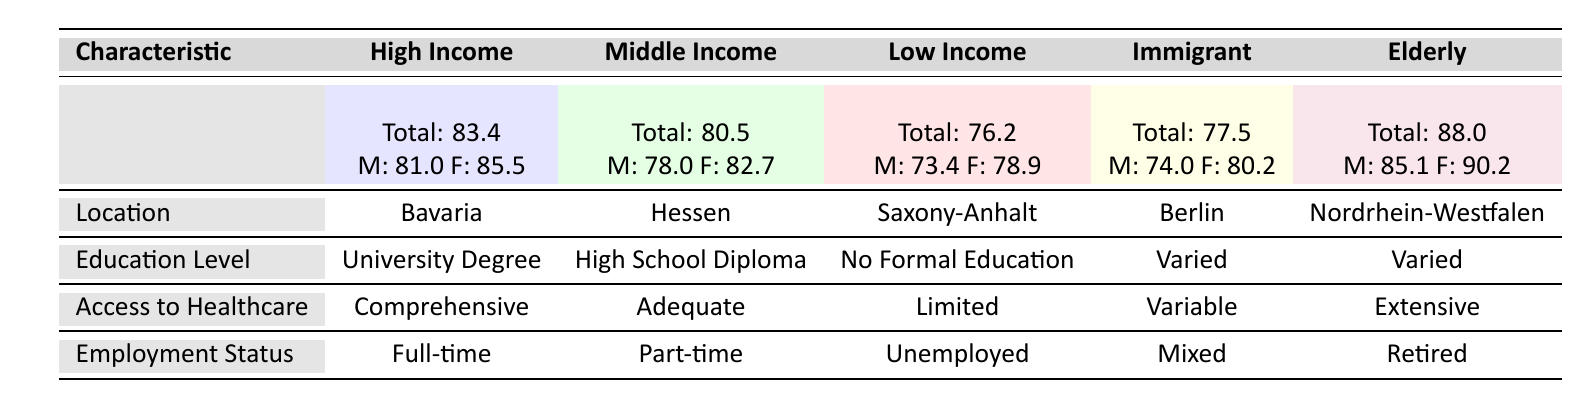What is the life expectancy for the elderly population in Nordrhein-Westfalen? The table shows the life expectancy for the elderly population is stated clearly under the "Life Expectancy" row for the "Elderly Population" group. It is listed as Total: 88.0.
Answer: 88.0 Which socio-economic group has the highest life expectancy for females? The table lists the life expectancy for females for each group. Comparing the values: High Income (85.5), Middle Income (82.7), Low Income (78.9), Immigrant Communities (80.2), and Elderly Population (90.2), it is evident that the Elderly Population has the highest life expectancy for females at 90.2.
Answer: Elderly Population How much higher is the total life expectancy of the High Income group compared to the Low Income group? The total life expectancy for the High Income group is 83.4 and for the Low Income group, it is 76.2. The difference is calculated as 83.4 - 76.2 = 7.2.
Answer: 7.2 Is access to healthcare comprehensive for the High Income group? The table indicates the access to healthcare for the High Income group is noted as "Comprehensive" under the "Access to Healthcare" row. Therefore, the statement is true.
Answer: Yes What is the average life expectancy for males across all socio-economic groups? The life expectancy for males is listed as follows: High Income (81.0), Middle Income (78.0), Low Income (73.4), Immigrant Communities (74.0), and Elderly Population (85.1). Summing these values gives 81.0 + 78.0 + 73.4 + 74.0 + 85.1 = 391.5. Since there are 5 groups, the average is calculated as 391.5 / 5 = 78.3.
Answer: 78.3 